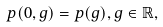Convert formula to latex. <formula><loc_0><loc_0><loc_500><loc_500>p ( 0 , g ) = p ( g ) , g \in \mathbb { R } ,</formula> 